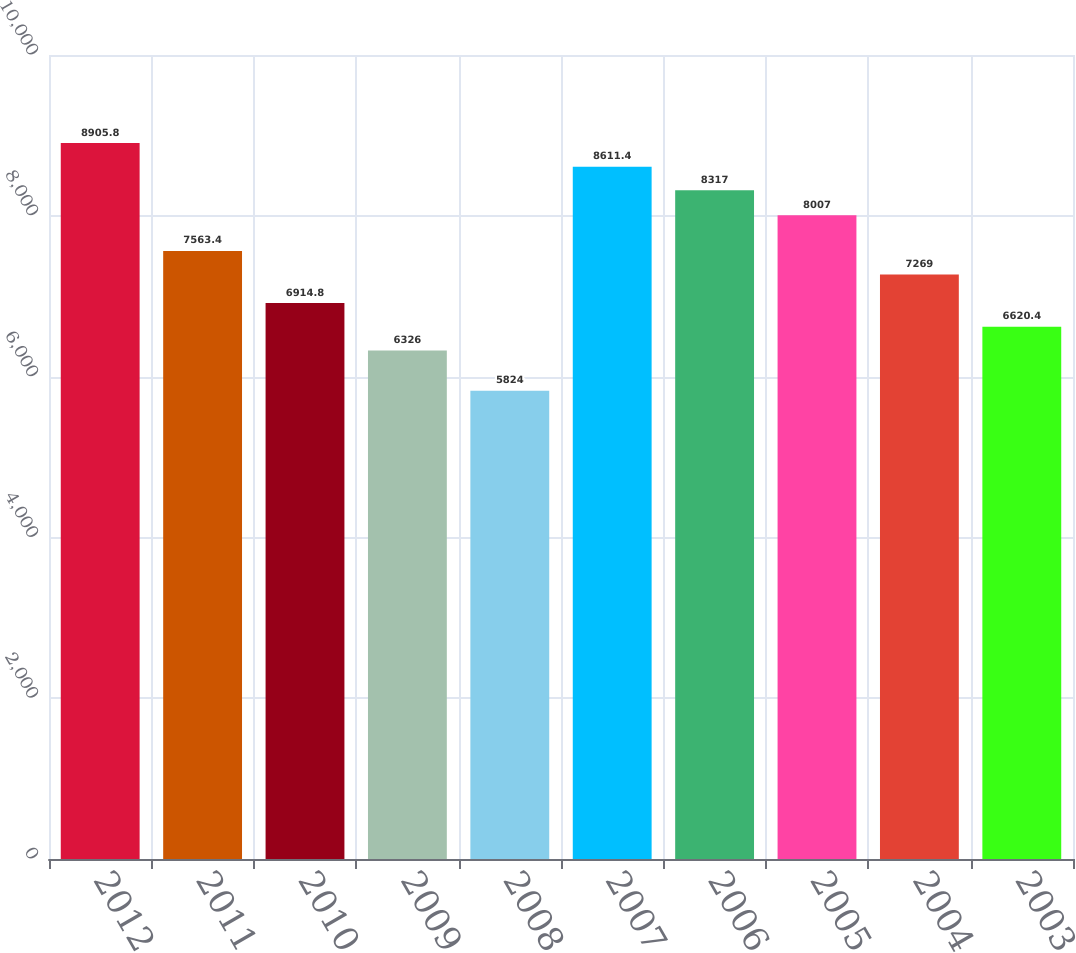Convert chart. <chart><loc_0><loc_0><loc_500><loc_500><bar_chart><fcel>2012<fcel>2011<fcel>2010<fcel>2009<fcel>2008<fcel>2007<fcel>2006<fcel>2005<fcel>2004<fcel>2003<nl><fcel>8905.8<fcel>7563.4<fcel>6914.8<fcel>6326<fcel>5824<fcel>8611.4<fcel>8317<fcel>8007<fcel>7269<fcel>6620.4<nl></chart> 